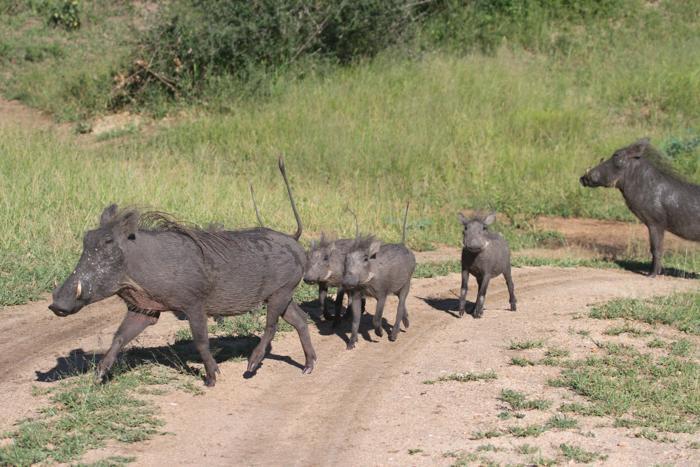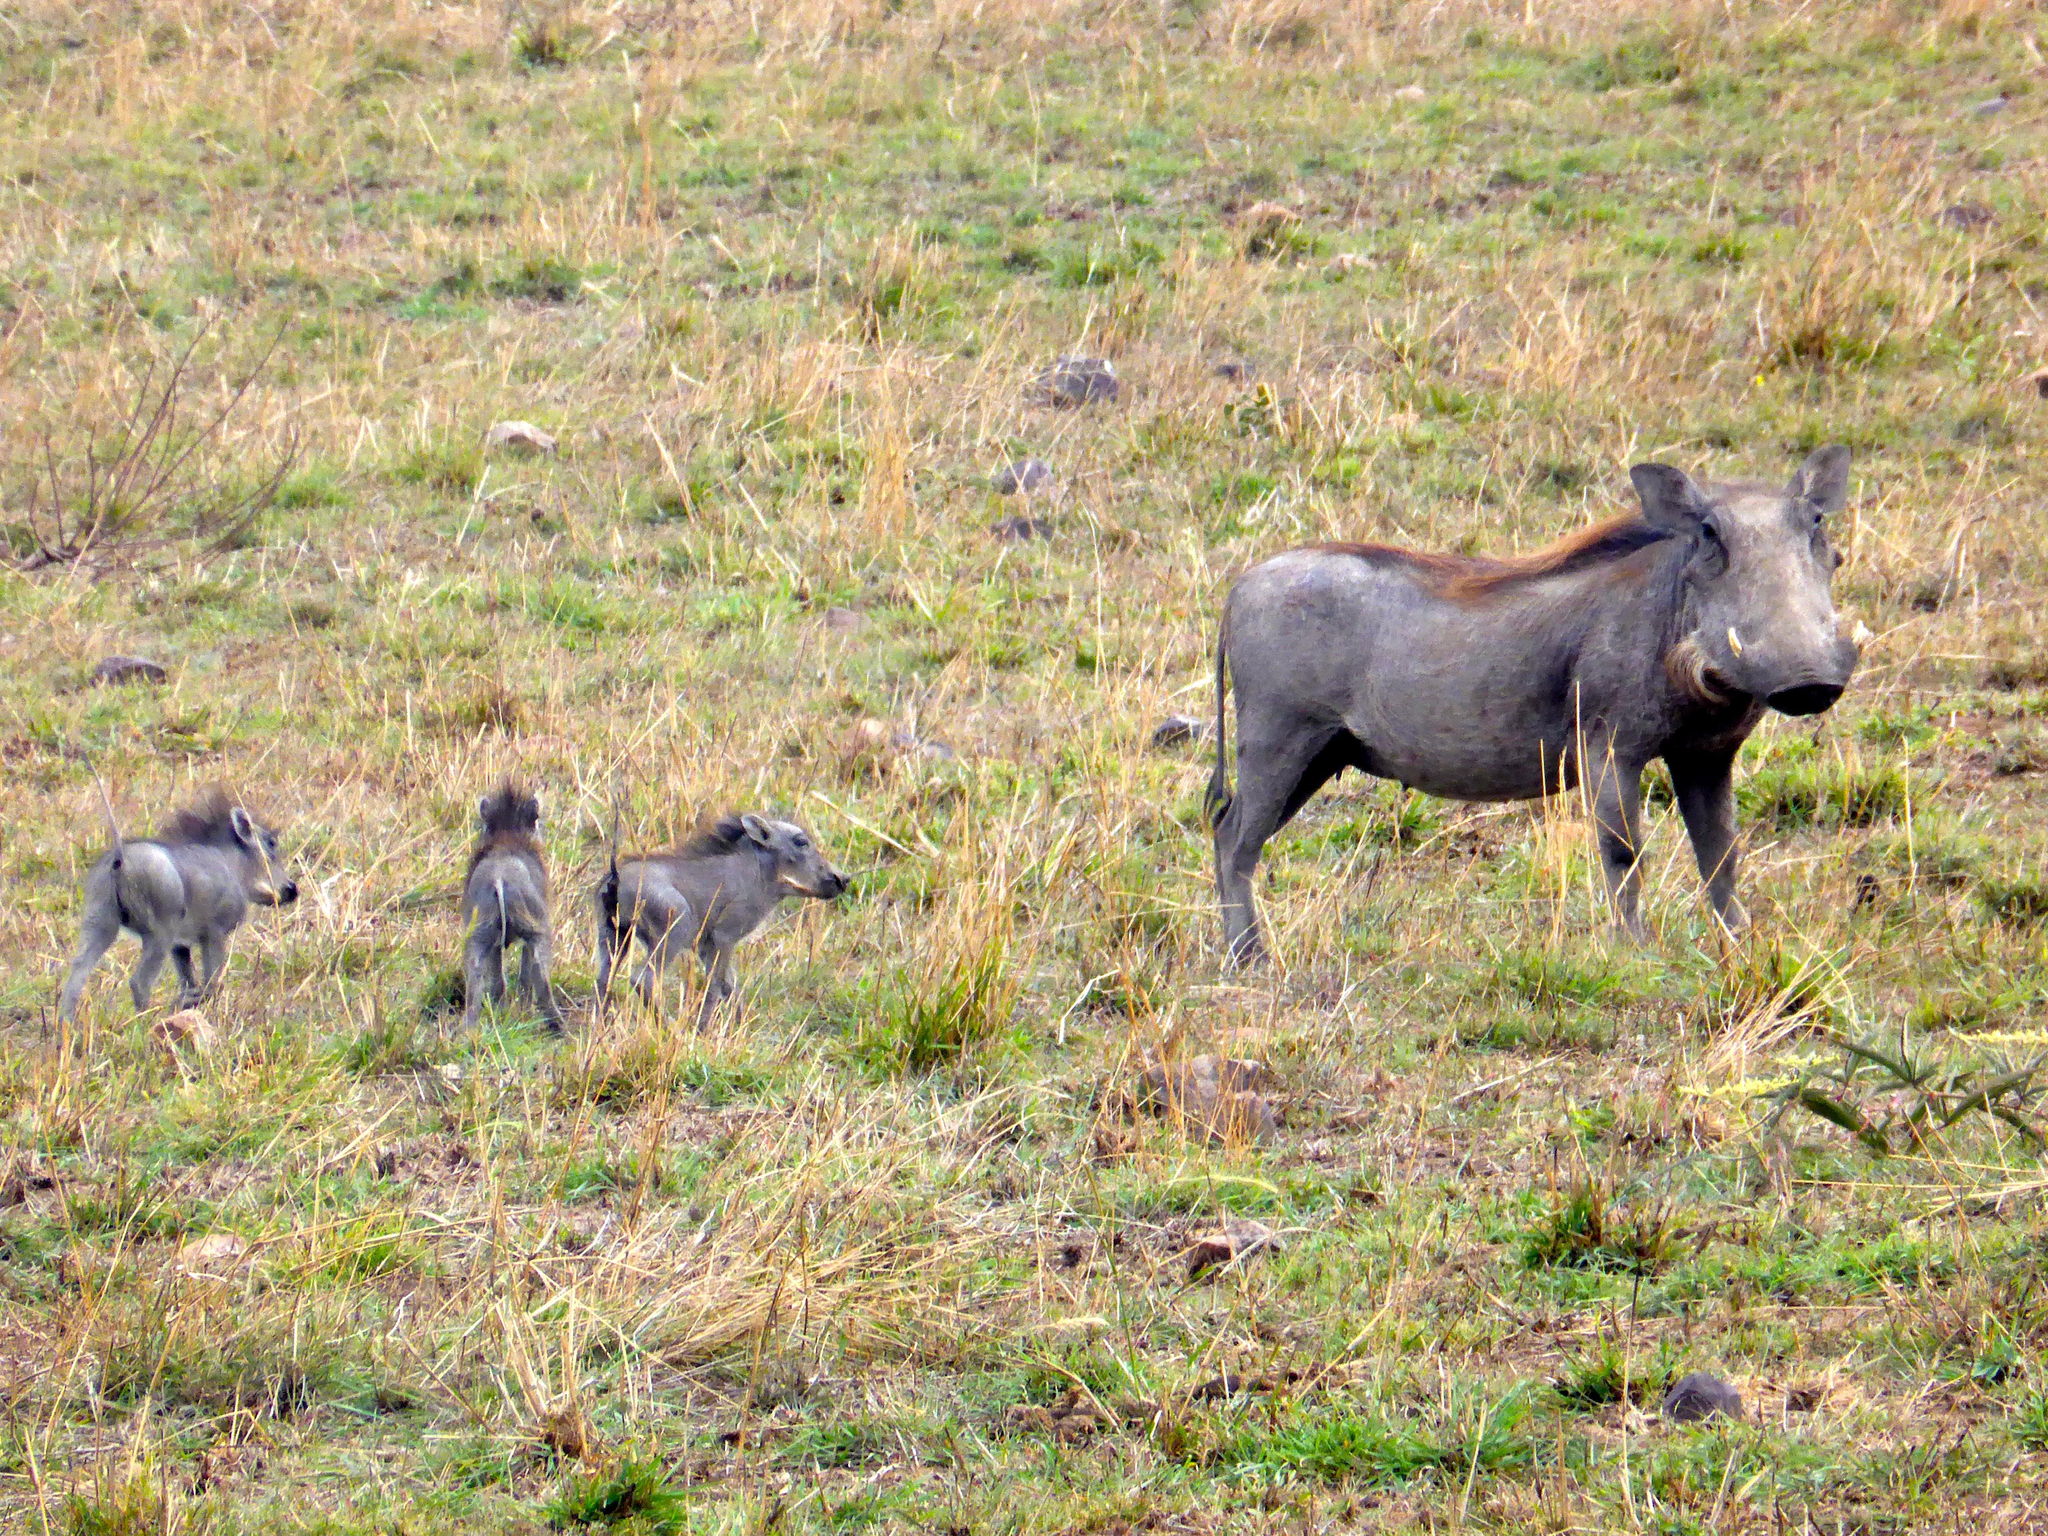The first image is the image on the left, the second image is the image on the right. Evaluate the accuracy of this statement regarding the images: "There is exactly one animal in the image on the left.". Is it true? Answer yes or no. No. The first image is the image on the left, the second image is the image on the right. Evaluate the accuracy of this statement regarding the images: "Left image shows one young hog running forward.". Is it true? Answer yes or no. No. 